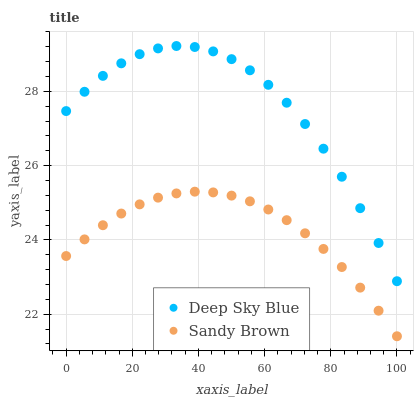Does Sandy Brown have the minimum area under the curve?
Answer yes or no. Yes. Does Deep Sky Blue have the maximum area under the curve?
Answer yes or no. Yes. Does Deep Sky Blue have the minimum area under the curve?
Answer yes or no. No. Is Sandy Brown the smoothest?
Answer yes or no. Yes. Is Deep Sky Blue the roughest?
Answer yes or no. Yes. Is Deep Sky Blue the smoothest?
Answer yes or no. No. Does Sandy Brown have the lowest value?
Answer yes or no. Yes. Does Deep Sky Blue have the lowest value?
Answer yes or no. No. Does Deep Sky Blue have the highest value?
Answer yes or no. Yes. Is Sandy Brown less than Deep Sky Blue?
Answer yes or no. Yes. Is Deep Sky Blue greater than Sandy Brown?
Answer yes or no. Yes. Does Sandy Brown intersect Deep Sky Blue?
Answer yes or no. No. 